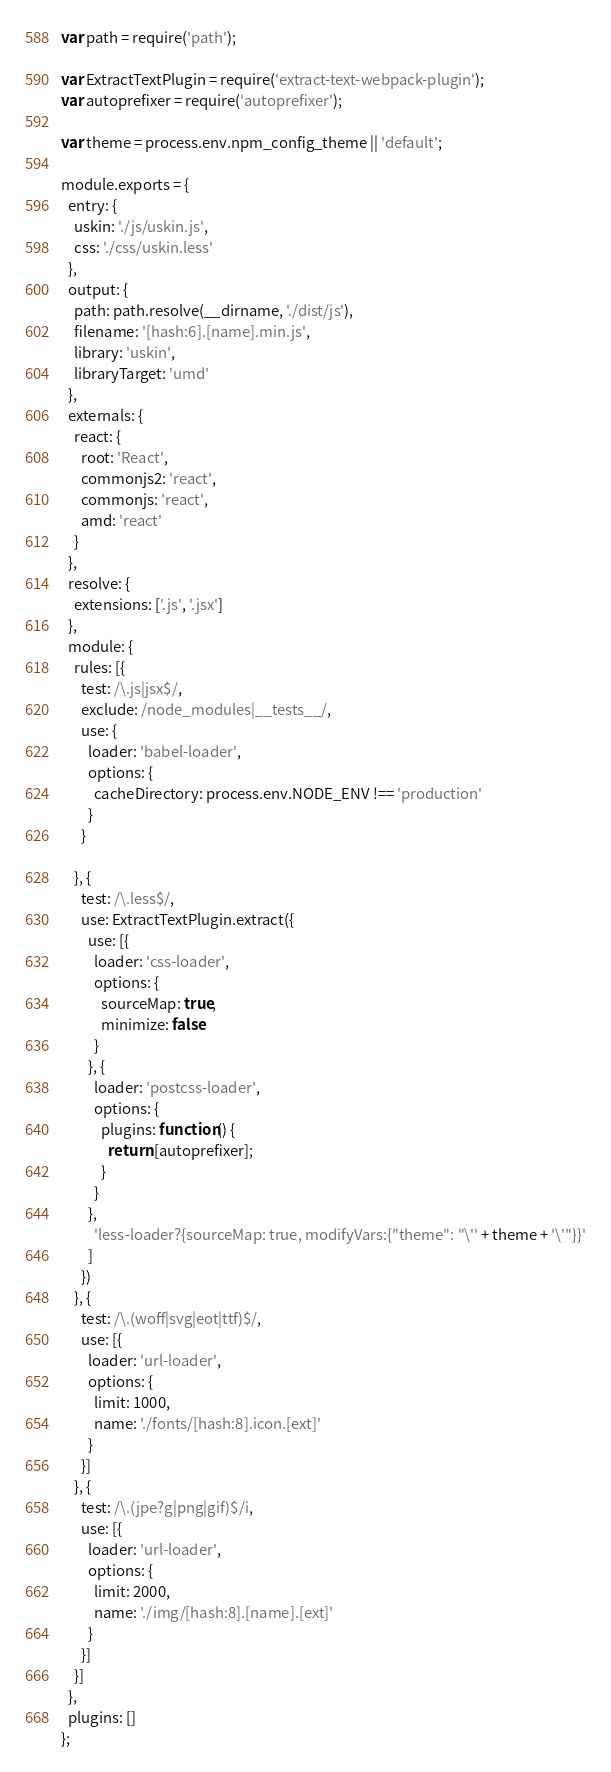Convert code to text. <code><loc_0><loc_0><loc_500><loc_500><_JavaScript_>var path = require('path');

var ExtractTextPlugin = require('extract-text-webpack-plugin');
var autoprefixer = require('autoprefixer');

var theme = process.env.npm_config_theme || 'default';

module.exports = {
  entry: {
    uskin: './js/uskin.js',
    css: './css/uskin.less'
  },
  output: {
    path: path.resolve(__dirname, './dist/js'),
    filename: '[hash:6].[name].min.js',
    library: 'uskin',
    libraryTarget: 'umd'
  },
  externals: {
    react: {
      root: 'React',
      commonjs2: 'react',
      commonjs: 'react',
      amd: 'react'
    }
  },
  resolve: {
    extensions: ['.js', '.jsx']
  },
  module: {
    rules: [{
      test: /\.js|jsx$/,
      exclude: /node_modules|__tests__/,
      use: {
        loader: 'babel-loader',
        options: {
          cacheDirectory: process.env.NODE_ENV !== 'production'
        }
      }

    }, {
      test: /\.less$/,
      use: ExtractTextPlugin.extract({
        use: [{
          loader: 'css-loader',
          options: {
            sourceMap: true,
            minimize: false
          }
        }, {
          loader: 'postcss-loader',
          options: {
            plugins: function() {
              return [autoprefixer];
            }
          }
        },
          'less-loader?{sourceMap: true, modifyVars:{"theme": "\'' + theme + '\'"}}'
        ]
      })
    }, {
      test: /\.(woff|svg|eot|ttf)$/,
      use: [{
        loader: 'url-loader',
        options: {
          limit: 1000,
          name: './fonts/[hash:8].icon.[ext]'
        }
      }]
    }, {
      test: /\.(jpe?g|png|gif)$/i,
      use: [{
        loader: 'url-loader',
        options: {
          limit: 2000,
          name: './img/[hash:8].[name].[ext]'
        }
      }]
    }]
  },
  plugins: []
};
</code> 